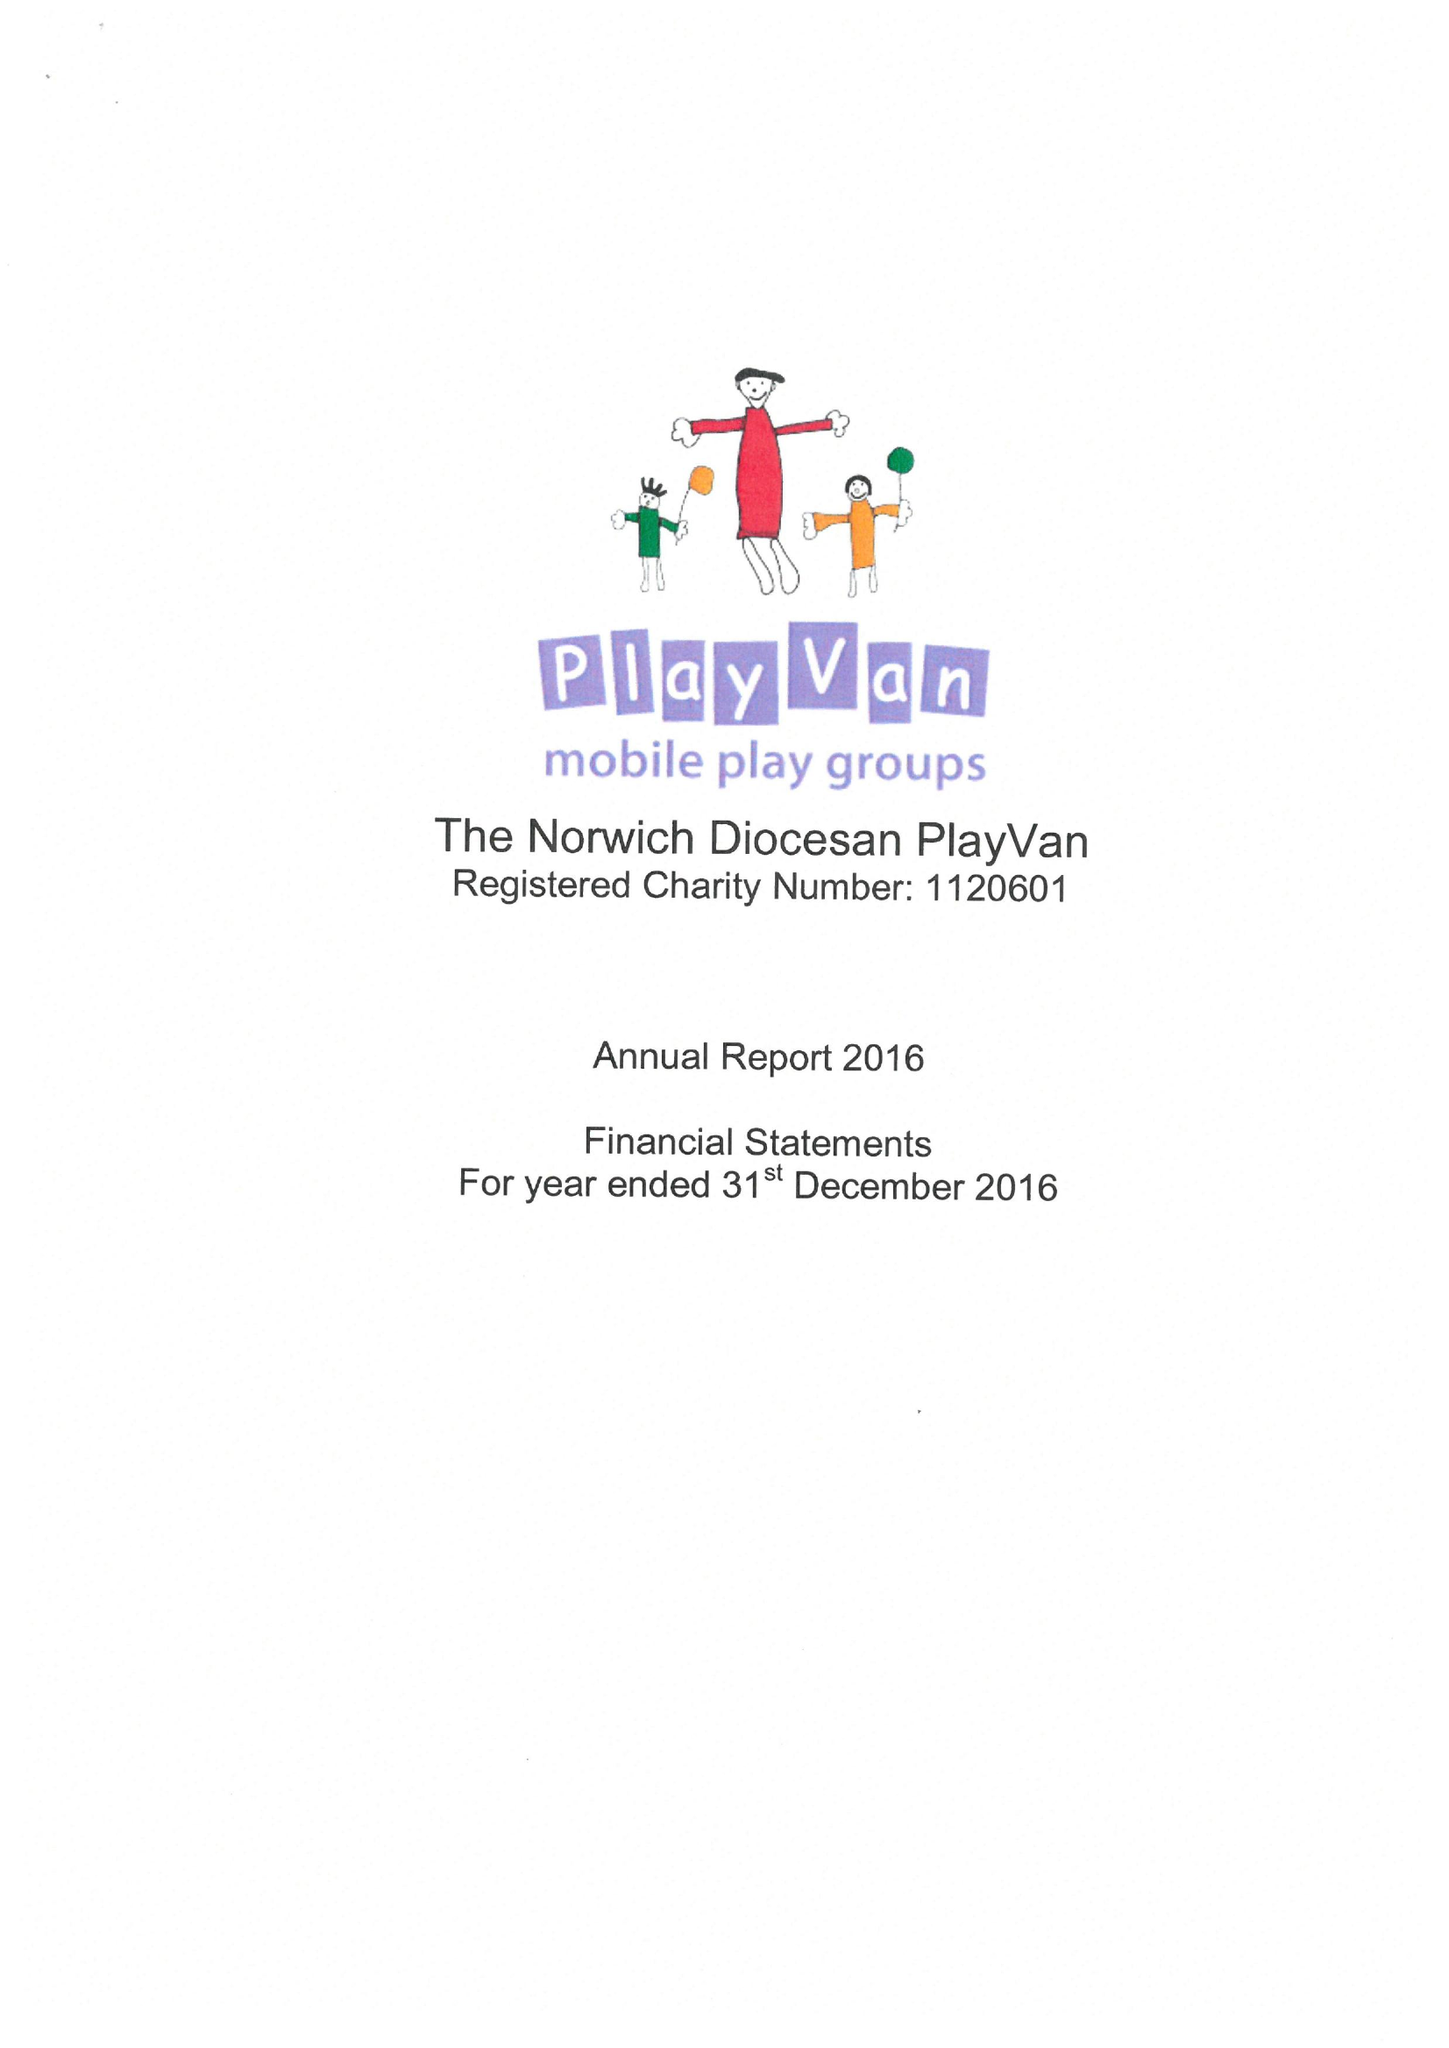What is the value for the address__street_line?
Answer the question using a single word or phrase. 109 DEREHAM ROAD 